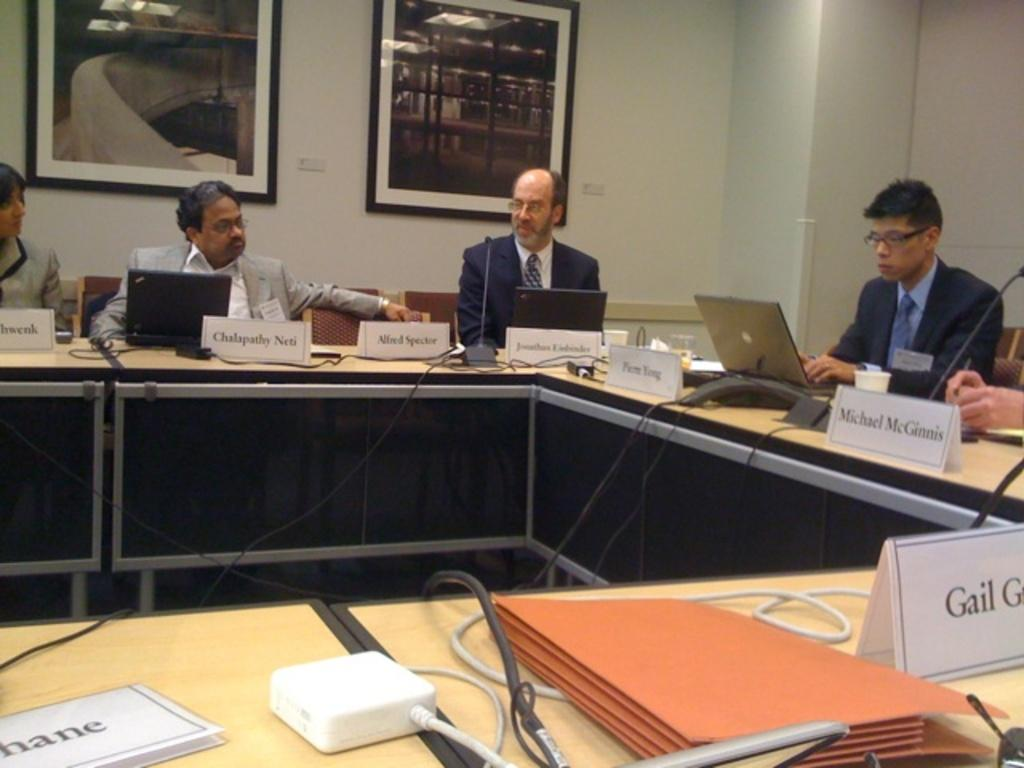<image>
Write a terse but informative summary of the picture. People in suits, including Michael McGinnis, sit around a U shaped table during a meeting. 